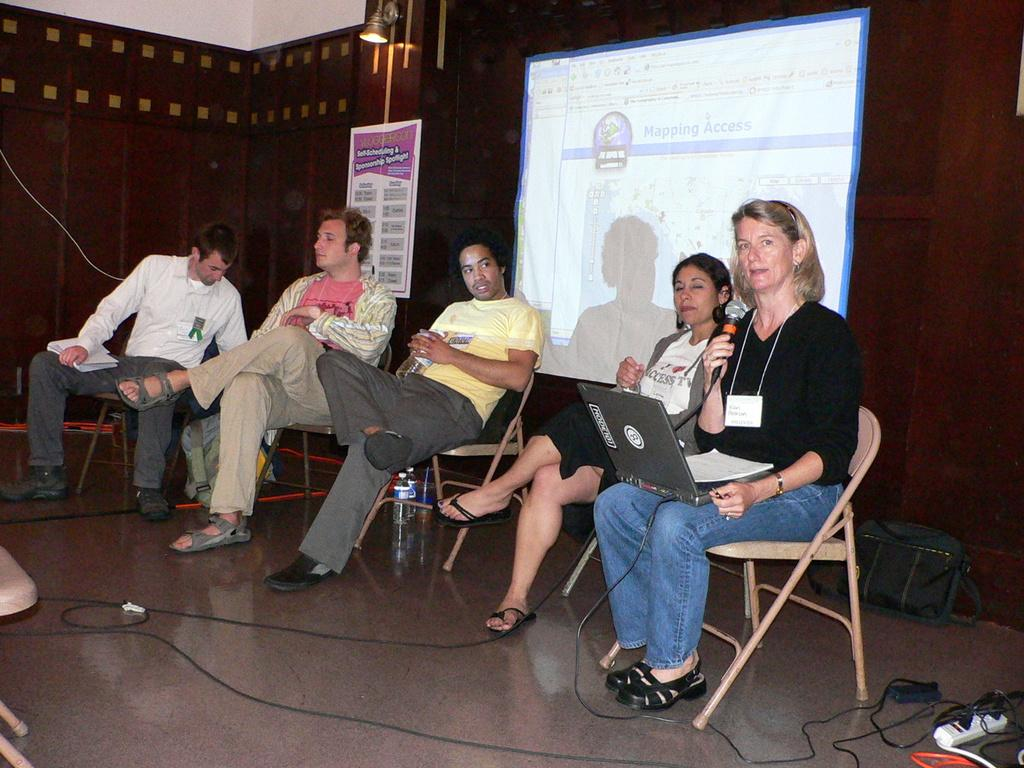How many people are in the image? There is a group of people in the image, but the exact number is not specified. What are the people doing in the image? The people are sitting on chairs in the image. What can be seen in the background of the image? There is a board, a light, and a screen in the background of the image. What type of plants can be seen growing on the chairs in the image? There are no plants visible on the chairs in the image. 